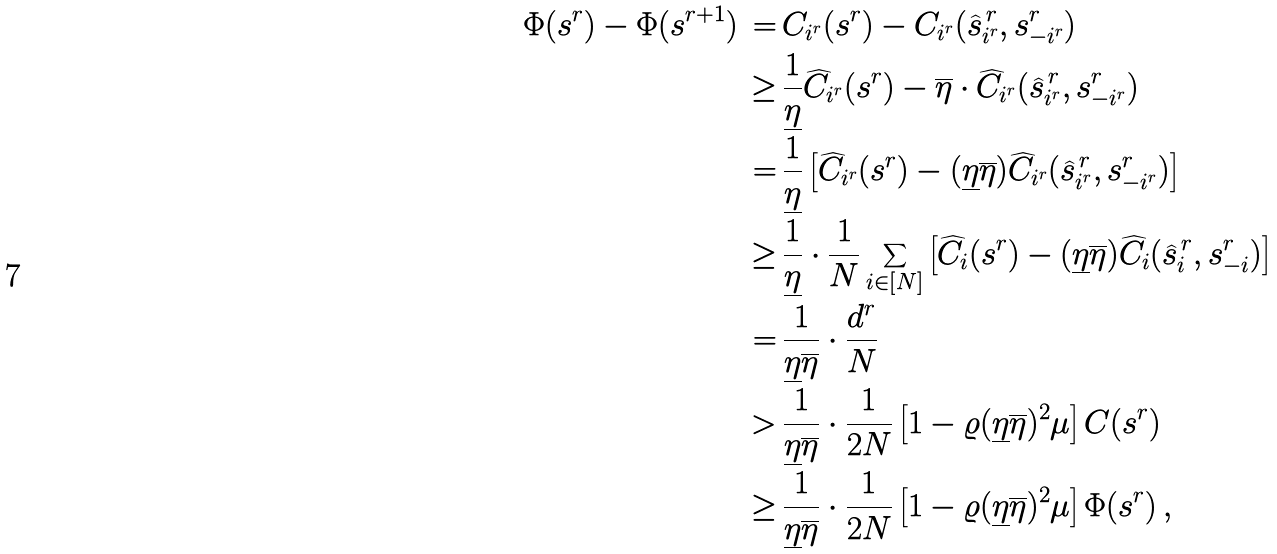Convert formula to latex. <formula><loc_0><loc_0><loc_500><loc_500>\Phi ( s ^ { r } ) - \Phi ( s ^ { r + 1 } ) \, = & \, C _ { i ^ { r } } ( s ^ { r } ) - C _ { i ^ { r } } ( \widehat { s } _ { i ^ { r } } ^ { \, r } , s _ { - i ^ { r } } ^ { r } ) \\ \geq & \, \frac { 1 } { \underline { \eta } } \widehat { C } _ { i ^ { r } } ( s ^ { r } ) - \overline { \eta } \cdot \widehat { C } _ { i ^ { r } } ( \widehat { s } _ { i ^ { r } } ^ { \, r } , s _ { - i ^ { r } } ^ { r } ) \\ = & \, \frac { 1 } { \underline { \eta } } \left [ \widehat { C } _ { i ^ { r } } ( s ^ { r } ) - ( \underline { \eta } \overline { \eta } ) \widehat { C } _ { i ^ { r } } ( \widehat { s } _ { i ^ { r } } ^ { \, r } , s _ { - i ^ { r } } ^ { r } ) \right ] \\ \geq & \, \frac { 1 } { \underline { \eta } } \cdot \frac { 1 } { N } \sum _ { i \in [ N ] } \left [ \widehat { C } _ { i } ( s ^ { r } ) - ( \underline { \eta } \overline { \eta } ) \widehat { C } _ { i } ( \widehat { s } _ { i } ^ { \, r } , s _ { - i } ^ { r } ) \right ] \\ = & \, \frac { 1 } { \underline { \eta } \overline { \eta } } \cdot \frac { d ^ { r } } { N } \\ > & \, \frac { 1 } { \underline { \eta } \overline { \eta } } \cdot \frac { 1 } { 2 N } \left [ 1 - \varrho ( \underline { \eta } \overline { \eta } ) ^ { 2 } \mu \right ] C ( s ^ { r } ) \\ \geq & \, \frac { 1 } { \underline { \eta } \overline { \eta } } \cdot \frac { 1 } { 2 N } \left [ 1 - \varrho ( \underline { \eta } \overline { \eta } ) ^ { 2 } \mu \right ] \Phi ( s ^ { r } ) \, ,</formula> 